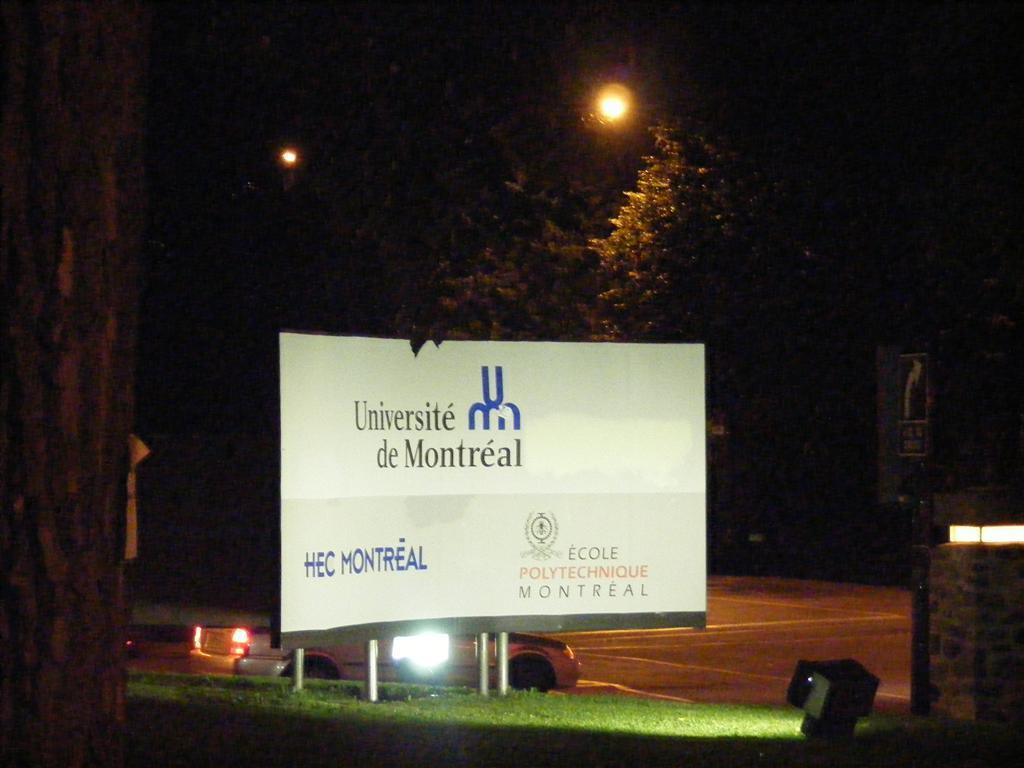<image>
Describe the image concisely. A sign lit up at night, with the University of Montreal logo on it on a white background. 